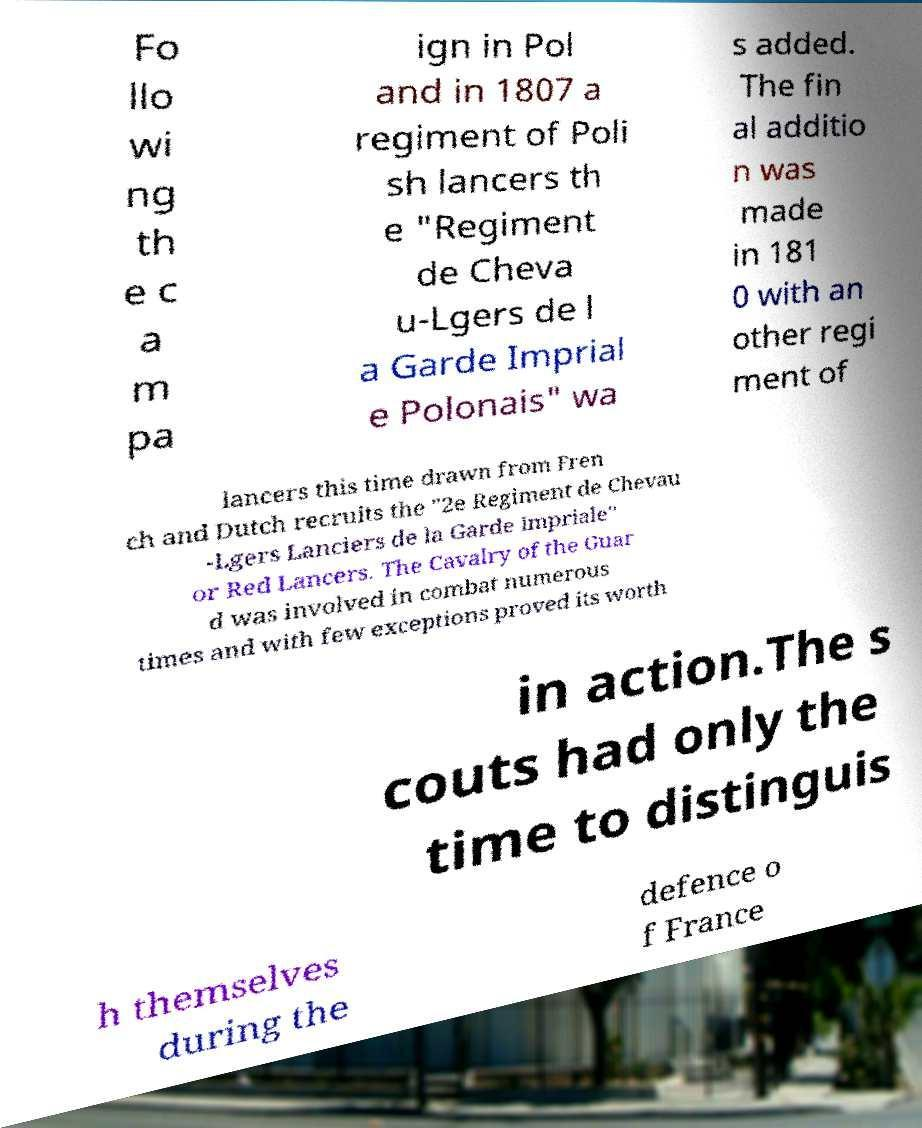Please read and relay the text visible in this image. What does it say? Fo llo wi ng th e c a m pa ign in Pol and in 1807 a regiment of Poli sh lancers th e "Regiment de Cheva u-Lgers de l a Garde Imprial e Polonais" wa s added. The fin al additio n was made in 181 0 with an other regi ment of lancers this time drawn from Fren ch and Dutch recruits the "2e Regiment de Chevau -Lgers Lanciers de la Garde Impriale" or Red Lancers. The Cavalry of the Guar d was involved in combat numerous times and with few exceptions proved its worth in action.The s couts had only the time to distinguis h themselves during the defence o f France 